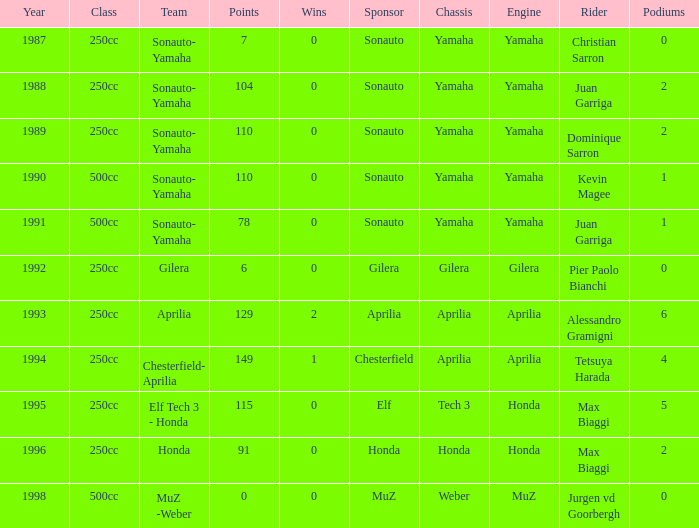How many wins did the team, which had more than 110 points, have in 1989? None. 